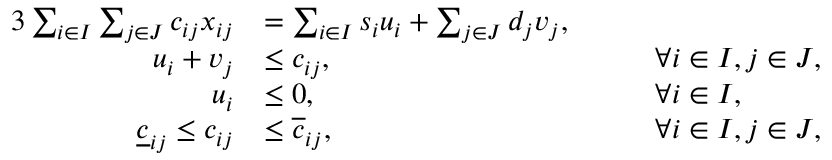<formula> <loc_0><loc_0><loc_500><loc_500>\begin{array} { r l r l } { { 3 } \sum _ { i \in I } \sum _ { j \in J } c _ { i j } x _ { i j } } & { = \sum _ { i \in I } s _ { i } u _ { i } + \sum _ { j \in J } d _ { j } v _ { j } , } \\ { u _ { i } + v _ { j } } & { \leq { c } _ { i j } , } & & { \forall i \in I , j \in J , } \\ { u _ { i } } & { \leq 0 , } & & { \forall i \in I , } \\ { \underline { c } _ { i j } \leq c _ { i j } } & { \leq \overline { c } _ { i j } , } & { \quad } & { \forall i \in I , j \in J , } \end{array}</formula> 